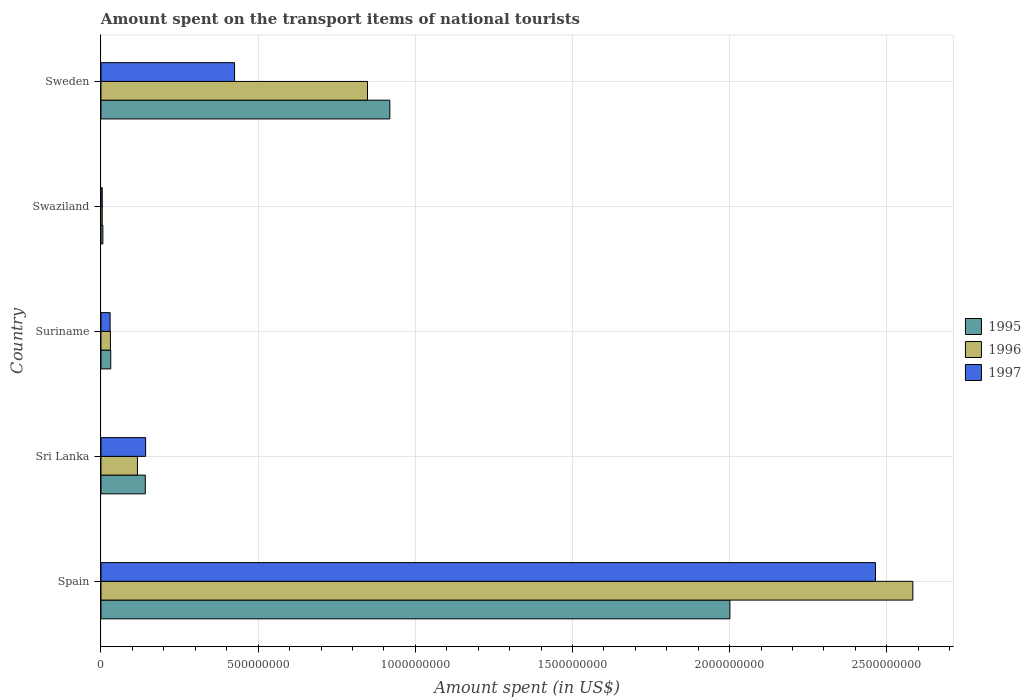How many different coloured bars are there?
Offer a terse response. 3. Are the number of bars per tick equal to the number of legend labels?
Provide a short and direct response. Yes. Are the number of bars on each tick of the Y-axis equal?
Provide a succinct answer. Yes. How many bars are there on the 1st tick from the bottom?
Keep it short and to the point. 3. What is the label of the 4th group of bars from the top?
Provide a succinct answer. Sri Lanka. What is the amount spent on the transport items of national tourists in 1995 in Sweden?
Offer a very short reply. 9.19e+08. Across all countries, what is the maximum amount spent on the transport items of national tourists in 1997?
Your answer should be very brief. 2.46e+09. Across all countries, what is the minimum amount spent on the transport items of national tourists in 1995?
Provide a succinct answer. 6.00e+06. In which country was the amount spent on the transport items of national tourists in 1995 minimum?
Provide a short and direct response. Swaziland. What is the total amount spent on the transport items of national tourists in 1995 in the graph?
Your answer should be very brief. 3.10e+09. What is the difference between the amount spent on the transport items of national tourists in 1996 in Suriname and that in Swaziland?
Your response must be concise. 2.60e+07. What is the difference between the amount spent on the transport items of national tourists in 1996 in Spain and the amount spent on the transport items of national tourists in 1995 in Suriname?
Offer a very short reply. 2.55e+09. What is the average amount spent on the transport items of national tourists in 1997 per country?
Give a very brief answer. 6.13e+08. What is the difference between the amount spent on the transport items of national tourists in 1995 and amount spent on the transport items of national tourists in 1996 in Suriname?
Ensure brevity in your answer.  1.00e+06. In how many countries, is the amount spent on the transport items of national tourists in 1997 greater than 300000000 US$?
Give a very brief answer. 2. What is the ratio of the amount spent on the transport items of national tourists in 1995 in Swaziland to that in Sweden?
Provide a succinct answer. 0.01. Is the amount spent on the transport items of national tourists in 1995 in Suriname less than that in Sweden?
Provide a short and direct response. Yes. What is the difference between the highest and the second highest amount spent on the transport items of national tourists in 1996?
Provide a succinct answer. 1.74e+09. What is the difference between the highest and the lowest amount spent on the transport items of national tourists in 1996?
Make the answer very short. 2.58e+09. In how many countries, is the amount spent on the transport items of national tourists in 1996 greater than the average amount spent on the transport items of national tourists in 1996 taken over all countries?
Keep it short and to the point. 2. Is the sum of the amount spent on the transport items of national tourists in 1997 in Sri Lanka and Swaziland greater than the maximum amount spent on the transport items of national tourists in 1996 across all countries?
Offer a terse response. No. Is it the case that in every country, the sum of the amount spent on the transport items of national tourists in 1996 and amount spent on the transport items of national tourists in 1997 is greater than the amount spent on the transport items of national tourists in 1995?
Keep it short and to the point. Yes. How many bars are there?
Keep it short and to the point. 15. How many countries are there in the graph?
Ensure brevity in your answer.  5. Does the graph contain any zero values?
Your answer should be compact. No. Where does the legend appear in the graph?
Ensure brevity in your answer.  Center right. How many legend labels are there?
Keep it short and to the point. 3. What is the title of the graph?
Give a very brief answer. Amount spent on the transport items of national tourists. What is the label or title of the X-axis?
Offer a very short reply. Amount spent (in US$). What is the Amount spent (in US$) of 1995 in Spain?
Offer a terse response. 2.00e+09. What is the Amount spent (in US$) in 1996 in Spain?
Your response must be concise. 2.58e+09. What is the Amount spent (in US$) in 1997 in Spain?
Your answer should be compact. 2.46e+09. What is the Amount spent (in US$) of 1995 in Sri Lanka?
Offer a terse response. 1.41e+08. What is the Amount spent (in US$) in 1996 in Sri Lanka?
Keep it short and to the point. 1.16e+08. What is the Amount spent (in US$) of 1997 in Sri Lanka?
Keep it short and to the point. 1.42e+08. What is the Amount spent (in US$) in 1995 in Suriname?
Provide a succinct answer. 3.10e+07. What is the Amount spent (in US$) in 1996 in Suriname?
Provide a short and direct response. 3.00e+07. What is the Amount spent (in US$) in 1997 in Suriname?
Offer a very short reply. 2.90e+07. What is the Amount spent (in US$) of 1997 in Swaziland?
Keep it short and to the point. 4.00e+06. What is the Amount spent (in US$) in 1995 in Sweden?
Your answer should be very brief. 9.19e+08. What is the Amount spent (in US$) in 1996 in Sweden?
Keep it short and to the point. 8.48e+08. What is the Amount spent (in US$) in 1997 in Sweden?
Make the answer very short. 4.25e+08. Across all countries, what is the maximum Amount spent (in US$) of 1995?
Make the answer very short. 2.00e+09. Across all countries, what is the maximum Amount spent (in US$) of 1996?
Keep it short and to the point. 2.58e+09. Across all countries, what is the maximum Amount spent (in US$) of 1997?
Provide a succinct answer. 2.46e+09. Across all countries, what is the minimum Amount spent (in US$) in 1995?
Give a very brief answer. 6.00e+06. Across all countries, what is the minimum Amount spent (in US$) in 1996?
Offer a terse response. 4.00e+06. Across all countries, what is the minimum Amount spent (in US$) of 1997?
Make the answer very short. 4.00e+06. What is the total Amount spent (in US$) of 1995 in the graph?
Give a very brief answer. 3.10e+09. What is the total Amount spent (in US$) in 1996 in the graph?
Offer a terse response. 3.58e+09. What is the total Amount spent (in US$) of 1997 in the graph?
Your answer should be compact. 3.06e+09. What is the difference between the Amount spent (in US$) of 1995 in Spain and that in Sri Lanka?
Ensure brevity in your answer.  1.86e+09. What is the difference between the Amount spent (in US$) in 1996 in Spain and that in Sri Lanka?
Your answer should be very brief. 2.47e+09. What is the difference between the Amount spent (in US$) in 1997 in Spain and that in Sri Lanka?
Make the answer very short. 2.32e+09. What is the difference between the Amount spent (in US$) in 1995 in Spain and that in Suriname?
Offer a very short reply. 1.97e+09. What is the difference between the Amount spent (in US$) of 1996 in Spain and that in Suriname?
Your answer should be compact. 2.55e+09. What is the difference between the Amount spent (in US$) in 1997 in Spain and that in Suriname?
Keep it short and to the point. 2.44e+09. What is the difference between the Amount spent (in US$) of 1995 in Spain and that in Swaziland?
Offer a very short reply. 2.00e+09. What is the difference between the Amount spent (in US$) of 1996 in Spain and that in Swaziland?
Offer a very short reply. 2.58e+09. What is the difference between the Amount spent (in US$) of 1997 in Spain and that in Swaziland?
Provide a succinct answer. 2.46e+09. What is the difference between the Amount spent (in US$) in 1995 in Spain and that in Sweden?
Give a very brief answer. 1.08e+09. What is the difference between the Amount spent (in US$) of 1996 in Spain and that in Sweden?
Keep it short and to the point. 1.74e+09. What is the difference between the Amount spent (in US$) of 1997 in Spain and that in Sweden?
Your answer should be very brief. 2.04e+09. What is the difference between the Amount spent (in US$) of 1995 in Sri Lanka and that in Suriname?
Provide a short and direct response. 1.10e+08. What is the difference between the Amount spent (in US$) of 1996 in Sri Lanka and that in Suriname?
Ensure brevity in your answer.  8.60e+07. What is the difference between the Amount spent (in US$) of 1997 in Sri Lanka and that in Suriname?
Give a very brief answer. 1.13e+08. What is the difference between the Amount spent (in US$) of 1995 in Sri Lanka and that in Swaziland?
Provide a succinct answer. 1.35e+08. What is the difference between the Amount spent (in US$) in 1996 in Sri Lanka and that in Swaziland?
Give a very brief answer. 1.12e+08. What is the difference between the Amount spent (in US$) in 1997 in Sri Lanka and that in Swaziland?
Provide a succinct answer. 1.38e+08. What is the difference between the Amount spent (in US$) of 1995 in Sri Lanka and that in Sweden?
Provide a short and direct response. -7.78e+08. What is the difference between the Amount spent (in US$) in 1996 in Sri Lanka and that in Sweden?
Give a very brief answer. -7.32e+08. What is the difference between the Amount spent (in US$) in 1997 in Sri Lanka and that in Sweden?
Make the answer very short. -2.83e+08. What is the difference between the Amount spent (in US$) in 1995 in Suriname and that in Swaziland?
Your response must be concise. 2.50e+07. What is the difference between the Amount spent (in US$) in 1996 in Suriname and that in Swaziland?
Offer a terse response. 2.60e+07. What is the difference between the Amount spent (in US$) in 1997 in Suriname and that in Swaziland?
Provide a short and direct response. 2.50e+07. What is the difference between the Amount spent (in US$) of 1995 in Suriname and that in Sweden?
Your response must be concise. -8.88e+08. What is the difference between the Amount spent (in US$) in 1996 in Suriname and that in Sweden?
Ensure brevity in your answer.  -8.18e+08. What is the difference between the Amount spent (in US$) in 1997 in Suriname and that in Sweden?
Provide a succinct answer. -3.96e+08. What is the difference between the Amount spent (in US$) in 1995 in Swaziland and that in Sweden?
Give a very brief answer. -9.13e+08. What is the difference between the Amount spent (in US$) in 1996 in Swaziland and that in Sweden?
Your response must be concise. -8.44e+08. What is the difference between the Amount spent (in US$) in 1997 in Swaziland and that in Sweden?
Keep it short and to the point. -4.21e+08. What is the difference between the Amount spent (in US$) in 1995 in Spain and the Amount spent (in US$) in 1996 in Sri Lanka?
Your answer should be very brief. 1.88e+09. What is the difference between the Amount spent (in US$) in 1995 in Spain and the Amount spent (in US$) in 1997 in Sri Lanka?
Make the answer very short. 1.86e+09. What is the difference between the Amount spent (in US$) in 1996 in Spain and the Amount spent (in US$) in 1997 in Sri Lanka?
Your answer should be compact. 2.44e+09. What is the difference between the Amount spent (in US$) in 1995 in Spain and the Amount spent (in US$) in 1996 in Suriname?
Make the answer very short. 1.97e+09. What is the difference between the Amount spent (in US$) in 1995 in Spain and the Amount spent (in US$) in 1997 in Suriname?
Your answer should be very brief. 1.97e+09. What is the difference between the Amount spent (in US$) in 1996 in Spain and the Amount spent (in US$) in 1997 in Suriname?
Your answer should be compact. 2.55e+09. What is the difference between the Amount spent (in US$) of 1995 in Spain and the Amount spent (in US$) of 1996 in Swaziland?
Keep it short and to the point. 2.00e+09. What is the difference between the Amount spent (in US$) of 1995 in Spain and the Amount spent (in US$) of 1997 in Swaziland?
Provide a short and direct response. 2.00e+09. What is the difference between the Amount spent (in US$) of 1996 in Spain and the Amount spent (in US$) of 1997 in Swaziland?
Offer a terse response. 2.58e+09. What is the difference between the Amount spent (in US$) in 1995 in Spain and the Amount spent (in US$) in 1996 in Sweden?
Your response must be concise. 1.15e+09. What is the difference between the Amount spent (in US$) in 1995 in Spain and the Amount spent (in US$) in 1997 in Sweden?
Provide a short and direct response. 1.58e+09. What is the difference between the Amount spent (in US$) of 1996 in Spain and the Amount spent (in US$) of 1997 in Sweden?
Offer a terse response. 2.16e+09. What is the difference between the Amount spent (in US$) in 1995 in Sri Lanka and the Amount spent (in US$) in 1996 in Suriname?
Your answer should be very brief. 1.11e+08. What is the difference between the Amount spent (in US$) of 1995 in Sri Lanka and the Amount spent (in US$) of 1997 in Suriname?
Make the answer very short. 1.12e+08. What is the difference between the Amount spent (in US$) in 1996 in Sri Lanka and the Amount spent (in US$) in 1997 in Suriname?
Make the answer very short. 8.70e+07. What is the difference between the Amount spent (in US$) in 1995 in Sri Lanka and the Amount spent (in US$) in 1996 in Swaziland?
Your response must be concise. 1.37e+08. What is the difference between the Amount spent (in US$) of 1995 in Sri Lanka and the Amount spent (in US$) of 1997 in Swaziland?
Provide a succinct answer. 1.37e+08. What is the difference between the Amount spent (in US$) in 1996 in Sri Lanka and the Amount spent (in US$) in 1997 in Swaziland?
Make the answer very short. 1.12e+08. What is the difference between the Amount spent (in US$) in 1995 in Sri Lanka and the Amount spent (in US$) in 1996 in Sweden?
Your answer should be compact. -7.07e+08. What is the difference between the Amount spent (in US$) in 1995 in Sri Lanka and the Amount spent (in US$) in 1997 in Sweden?
Ensure brevity in your answer.  -2.84e+08. What is the difference between the Amount spent (in US$) in 1996 in Sri Lanka and the Amount spent (in US$) in 1997 in Sweden?
Ensure brevity in your answer.  -3.09e+08. What is the difference between the Amount spent (in US$) of 1995 in Suriname and the Amount spent (in US$) of 1996 in Swaziland?
Offer a very short reply. 2.70e+07. What is the difference between the Amount spent (in US$) of 1995 in Suriname and the Amount spent (in US$) of 1997 in Swaziland?
Your response must be concise. 2.70e+07. What is the difference between the Amount spent (in US$) in 1996 in Suriname and the Amount spent (in US$) in 1997 in Swaziland?
Provide a succinct answer. 2.60e+07. What is the difference between the Amount spent (in US$) of 1995 in Suriname and the Amount spent (in US$) of 1996 in Sweden?
Keep it short and to the point. -8.17e+08. What is the difference between the Amount spent (in US$) in 1995 in Suriname and the Amount spent (in US$) in 1997 in Sweden?
Give a very brief answer. -3.94e+08. What is the difference between the Amount spent (in US$) of 1996 in Suriname and the Amount spent (in US$) of 1997 in Sweden?
Keep it short and to the point. -3.95e+08. What is the difference between the Amount spent (in US$) in 1995 in Swaziland and the Amount spent (in US$) in 1996 in Sweden?
Your answer should be very brief. -8.42e+08. What is the difference between the Amount spent (in US$) in 1995 in Swaziland and the Amount spent (in US$) in 1997 in Sweden?
Provide a succinct answer. -4.19e+08. What is the difference between the Amount spent (in US$) in 1996 in Swaziland and the Amount spent (in US$) in 1997 in Sweden?
Offer a terse response. -4.21e+08. What is the average Amount spent (in US$) in 1995 per country?
Provide a succinct answer. 6.20e+08. What is the average Amount spent (in US$) in 1996 per country?
Your response must be concise. 7.16e+08. What is the average Amount spent (in US$) in 1997 per country?
Ensure brevity in your answer.  6.13e+08. What is the difference between the Amount spent (in US$) in 1995 and Amount spent (in US$) in 1996 in Spain?
Ensure brevity in your answer.  -5.82e+08. What is the difference between the Amount spent (in US$) in 1995 and Amount spent (in US$) in 1997 in Spain?
Keep it short and to the point. -4.63e+08. What is the difference between the Amount spent (in US$) in 1996 and Amount spent (in US$) in 1997 in Spain?
Provide a succinct answer. 1.19e+08. What is the difference between the Amount spent (in US$) in 1995 and Amount spent (in US$) in 1996 in Sri Lanka?
Keep it short and to the point. 2.50e+07. What is the difference between the Amount spent (in US$) in 1996 and Amount spent (in US$) in 1997 in Sri Lanka?
Your answer should be compact. -2.60e+07. What is the difference between the Amount spent (in US$) in 1995 and Amount spent (in US$) in 1996 in Suriname?
Provide a short and direct response. 1.00e+06. What is the difference between the Amount spent (in US$) in 1995 and Amount spent (in US$) in 1996 in Swaziland?
Offer a very short reply. 2.00e+06. What is the difference between the Amount spent (in US$) in 1995 and Amount spent (in US$) in 1996 in Sweden?
Provide a succinct answer. 7.10e+07. What is the difference between the Amount spent (in US$) in 1995 and Amount spent (in US$) in 1997 in Sweden?
Your answer should be compact. 4.94e+08. What is the difference between the Amount spent (in US$) of 1996 and Amount spent (in US$) of 1997 in Sweden?
Offer a very short reply. 4.23e+08. What is the ratio of the Amount spent (in US$) of 1995 in Spain to that in Sri Lanka?
Ensure brevity in your answer.  14.19. What is the ratio of the Amount spent (in US$) in 1996 in Spain to that in Sri Lanka?
Give a very brief answer. 22.27. What is the ratio of the Amount spent (in US$) in 1997 in Spain to that in Sri Lanka?
Offer a very short reply. 17.35. What is the ratio of the Amount spent (in US$) of 1995 in Spain to that in Suriname?
Make the answer very short. 64.55. What is the ratio of the Amount spent (in US$) in 1996 in Spain to that in Suriname?
Ensure brevity in your answer.  86.1. What is the ratio of the Amount spent (in US$) of 1997 in Spain to that in Suriname?
Provide a succinct answer. 84.97. What is the ratio of the Amount spent (in US$) in 1995 in Spain to that in Swaziland?
Keep it short and to the point. 333.5. What is the ratio of the Amount spent (in US$) in 1996 in Spain to that in Swaziland?
Offer a terse response. 645.75. What is the ratio of the Amount spent (in US$) of 1997 in Spain to that in Swaziland?
Your answer should be compact. 616. What is the ratio of the Amount spent (in US$) in 1995 in Spain to that in Sweden?
Provide a succinct answer. 2.18. What is the ratio of the Amount spent (in US$) of 1996 in Spain to that in Sweden?
Your response must be concise. 3.05. What is the ratio of the Amount spent (in US$) in 1997 in Spain to that in Sweden?
Provide a short and direct response. 5.8. What is the ratio of the Amount spent (in US$) in 1995 in Sri Lanka to that in Suriname?
Offer a very short reply. 4.55. What is the ratio of the Amount spent (in US$) of 1996 in Sri Lanka to that in Suriname?
Your answer should be very brief. 3.87. What is the ratio of the Amount spent (in US$) in 1997 in Sri Lanka to that in Suriname?
Offer a terse response. 4.9. What is the ratio of the Amount spent (in US$) of 1995 in Sri Lanka to that in Swaziland?
Your answer should be compact. 23.5. What is the ratio of the Amount spent (in US$) in 1996 in Sri Lanka to that in Swaziland?
Offer a very short reply. 29. What is the ratio of the Amount spent (in US$) of 1997 in Sri Lanka to that in Swaziland?
Provide a succinct answer. 35.5. What is the ratio of the Amount spent (in US$) in 1995 in Sri Lanka to that in Sweden?
Your response must be concise. 0.15. What is the ratio of the Amount spent (in US$) of 1996 in Sri Lanka to that in Sweden?
Keep it short and to the point. 0.14. What is the ratio of the Amount spent (in US$) in 1997 in Sri Lanka to that in Sweden?
Offer a very short reply. 0.33. What is the ratio of the Amount spent (in US$) in 1995 in Suriname to that in Swaziland?
Keep it short and to the point. 5.17. What is the ratio of the Amount spent (in US$) of 1996 in Suriname to that in Swaziland?
Your response must be concise. 7.5. What is the ratio of the Amount spent (in US$) in 1997 in Suriname to that in Swaziland?
Offer a very short reply. 7.25. What is the ratio of the Amount spent (in US$) in 1995 in Suriname to that in Sweden?
Your answer should be compact. 0.03. What is the ratio of the Amount spent (in US$) in 1996 in Suriname to that in Sweden?
Your answer should be very brief. 0.04. What is the ratio of the Amount spent (in US$) in 1997 in Suriname to that in Sweden?
Ensure brevity in your answer.  0.07. What is the ratio of the Amount spent (in US$) in 1995 in Swaziland to that in Sweden?
Offer a very short reply. 0.01. What is the ratio of the Amount spent (in US$) of 1996 in Swaziland to that in Sweden?
Keep it short and to the point. 0. What is the ratio of the Amount spent (in US$) of 1997 in Swaziland to that in Sweden?
Make the answer very short. 0.01. What is the difference between the highest and the second highest Amount spent (in US$) in 1995?
Provide a short and direct response. 1.08e+09. What is the difference between the highest and the second highest Amount spent (in US$) of 1996?
Make the answer very short. 1.74e+09. What is the difference between the highest and the second highest Amount spent (in US$) in 1997?
Your answer should be very brief. 2.04e+09. What is the difference between the highest and the lowest Amount spent (in US$) in 1995?
Provide a short and direct response. 2.00e+09. What is the difference between the highest and the lowest Amount spent (in US$) in 1996?
Provide a short and direct response. 2.58e+09. What is the difference between the highest and the lowest Amount spent (in US$) of 1997?
Keep it short and to the point. 2.46e+09. 